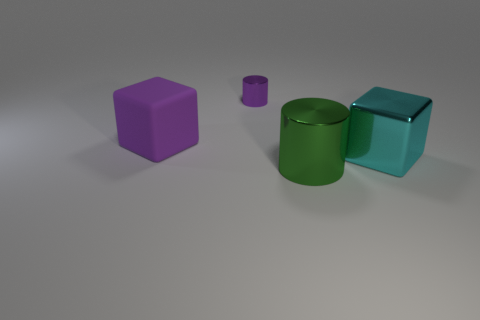What is the thing on the left side of the object behind the purple block made of?
Offer a very short reply. Rubber. What number of things are purple things or metallic cylinders that are behind the matte thing?
Offer a terse response. 2. What is the size of the other purple cylinder that is made of the same material as the large cylinder?
Your answer should be compact. Small. Is the number of large metallic cubes that are in front of the big purple rubber block greater than the number of brown shiny spheres?
Offer a very short reply. Yes. What is the size of the object that is to the right of the large rubber block and behind the metal cube?
Ensure brevity in your answer.  Small. There is another big thing that is the same shape as the big cyan object; what is its material?
Make the answer very short. Rubber. There is a purple object behind the purple rubber block; is it the same size as the green metallic thing?
Your answer should be very brief. No. There is a metal thing that is to the left of the large cyan thing and on the right side of the purple metallic cylinder; what is its color?
Offer a terse response. Green. There is a purple metallic thing behind the shiny block; what number of large cylinders are left of it?
Keep it short and to the point. 0. Is the tiny thing the same shape as the matte thing?
Give a very brief answer. No. 